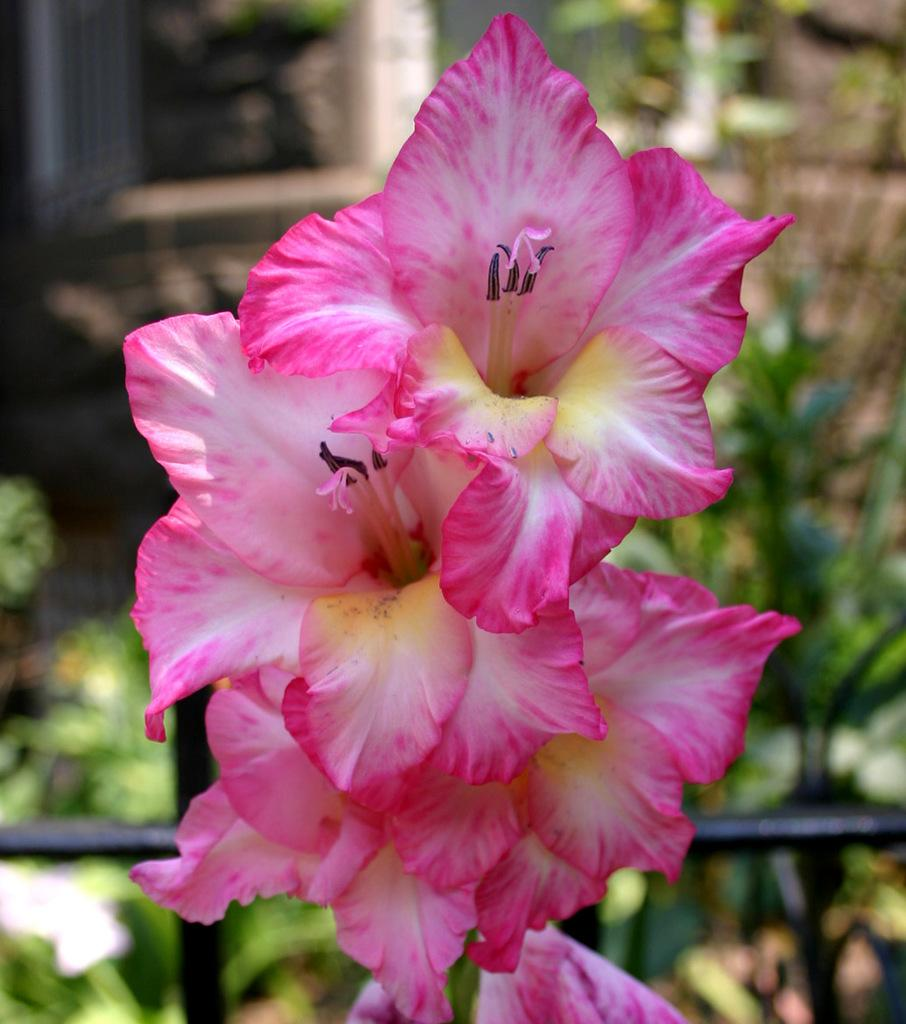What type of flora can be seen in the image? There are flowers in the image. What color are the flowers? The flowers are pink in color. Are there any other plants visible in the image? Yes, there are plants in the image. Can you describe the background of the image? The background of the image is blurred. How many suits are hanging in the background of the image? There are no suits present in the image; it features flowers and plants. Can you tell me how many cats are resting on the plants in the image? There are no cats present in the image; it only features flowers and plants. 